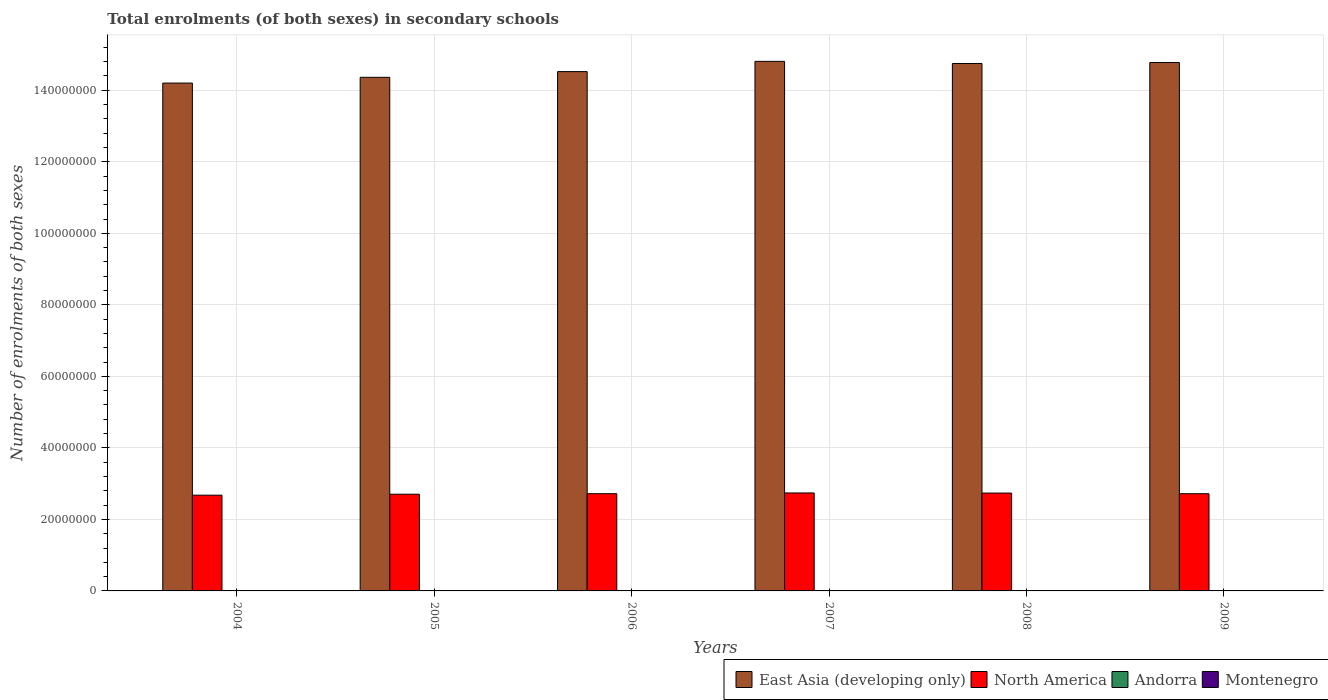How many different coloured bars are there?
Your answer should be compact. 4. How many groups of bars are there?
Provide a succinct answer. 6. Are the number of bars per tick equal to the number of legend labels?
Give a very brief answer. Yes. Are the number of bars on each tick of the X-axis equal?
Your response must be concise. Yes. How many bars are there on the 5th tick from the right?
Offer a terse response. 4. What is the number of enrolments in secondary schools in North America in 2005?
Provide a succinct answer. 2.70e+07. Across all years, what is the maximum number of enrolments in secondary schools in North America?
Ensure brevity in your answer.  2.74e+07. Across all years, what is the minimum number of enrolments in secondary schools in Andorra?
Give a very brief answer. 3250. In which year was the number of enrolments in secondary schools in Andorra minimum?
Make the answer very short. 2004. What is the total number of enrolments in secondary schools in Andorra in the graph?
Your answer should be compact. 2.24e+04. What is the difference between the number of enrolments in secondary schools in East Asia (developing only) in 2007 and that in 2008?
Keep it short and to the point. 5.97e+05. What is the difference between the number of enrolments in secondary schools in Andorra in 2008 and the number of enrolments in secondary schools in Montenegro in 2005?
Provide a succinct answer. -6.46e+04. What is the average number of enrolments in secondary schools in North America per year?
Your answer should be compact. 2.72e+07. In the year 2005, what is the difference between the number of enrolments in secondary schools in Montenegro and number of enrolments in secondary schools in North America?
Provide a short and direct response. -2.70e+07. What is the ratio of the number of enrolments in secondary schools in Montenegro in 2004 to that in 2008?
Your response must be concise. 1.03. What is the difference between the highest and the second highest number of enrolments in secondary schools in East Asia (developing only)?
Provide a short and direct response. 3.27e+05. What is the difference between the highest and the lowest number of enrolments in secondary schools in East Asia (developing only)?
Your answer should be compact. 6.07e+06. Is the sum of the number of enrolments in secondary schools in Montenegro in 2005 and 2007 greater than the maximum number of enrolments in secondary schools in North America across all years?
Provide a succinct answer. No. Is it the case that in every year, the sum of the number of enrolments in secondary schools in North America and number of enrolments in secondary schools in Montenegro is greater than the sum of number of enrolments in secondary schools in East Asia (developing only) and number of enrolments in secondary schools in Andorra?
Provide a succinct answer. No. What does the 4th bar from the left in 2006 represents?
Offer a terse response. Montenegro. What does the 1st bar from the right in 2006 represents?
Make the answer very short. Montenegro. Are all the bars in the graph horizontal?
Your answer should be very brief. No. How many years are there in the graph?
Ensure brevity in your answer.  6. Are the values on the major ticks of Y-axis written in scientific E-notation?
Give a very brief answer. No. Where does the legend appear in the graph?
Your response must be concise. Bottom right. How many legend labels are there?
Your answer should be compact. 4. What is the title of the graph?
Make the answer very short. Total enrolments (of both sexes) in secondary schools. Does "Vietnam" appear as one of the legend labels in the graph?
Your answer should be very brief. No. What is the label or title of the X-axis?
Offer a very short reply. Years. What is the label or title of the Y-axis?
Ensure brevity in your answer.  Number of enrolments of both sexes. What is the Number of enrolments of both sexes of East Asia (developing only) in 2004?
Your answer should be compact. 1.42e+08. What is the Number of enrolments of both sexes of North America in 2004?
Make the answer very short. 2.68e+07. What is the Number of enrolments of both sexes in Andorra in 2004?
Ensure brevity in your answer.  3250. What is the Number of enrolments of both sexes of Montenegro in 2004?
Keep it short and to the point. 6.88e+04. What is the Number of enrolments of both sexes of East Asia (developing only) in 2005?
Give a very brief answer. 1.44e+08. What is the Number of enrolments of both sexes in North America in 2005?
Make the answer very short. 2.70e+07. What is the Number of enrolments of both sexes of Andorra in 2005?
Offer a terse response. 3737. What is the Number of enrolments of both sexes of Montenegro in 2005?
Offer a very short reply. 6.85e+04. What is the Number of enrolments of both sexes in East Asia (developing only) in 2006?
Your answer should be very brief. 1.45e+08. What is the Number of enrolments of both sexes of North America in 2006?
Offer a terse response. 2.72e+07. What is the Number of enrolments of both sexes in Andorra in 2006?
Provide a succinct answer. 3843. What is the Number of enrolments of both sexes of Montenegro in 2006?
Make the answer very short. 6.82e+04. What is the Number of enrolments of both sexes of East Asia (developing only) in 2007?
Offer a very short reply. 1.48e+08. What is the Number of enrolments of both sexes in North America in 2007?
Ensure brevity in your answer.  2.74e+07. What is the Number of enrolments of both sexes of Andorra in 2007?
Offer a very short reply. 3819. What is the Number of enrolments of both sexes of Montenegro in 2007?
Give a very brief answer. 6.77e+04. What is the Number of enrolments of both sexes in East Asia (developing only) in 2008?
Keep it short and to the point. 1.47e+08. What is the Number of enrolments of both sexes in North America in 2008?
Your answer should be very brief. 2.74e+07. What is the Number of enrolments of both sexes of Andorra in 2008?
Your response must be concise. 3851. What is the Number of enrolments of both sexes in Montenegro in 2008?
Your response must be concise. 6.70e+04. What is the Number of enrolments of both sexes in East Asia (developing only) in 2009?
Your answer should be very brief. 1.48e+08. What is the Number of enrolments of both sexes of North America in 2009?
Provide a succinct answer. 2.72e+07. What is the Number of enrolments of both sexes of Andorra in 2009?
Give a very brief answer. 3914. What is the Number of enrolments of both sexes in Montenegro in 2009?
Offer a terse response. 6.81e+04. Across all years, what is the maximum Number of enrolments of both sexes in East Asia (developing only)?
Provide a succinct answer. 1.48e+08. Across all years, what is the maximum Number of enrolments of both sexes in North America?
Provide a succinct answer. 2.74e+07. Across all years, what is the maximum Number of enrolments of both sexes of Andorra?
Provide a succinct answer. 3914. Across all years, what is the maximum Number of enrolments of both sexes in Montenegro?
Offer a very short reply. 6.88e+04. Across all years, what is the minimum Number of enrolments of both sexes of East Asia (developing only)?
Your answer should be very brief. 1.42e+08. Across all years, what is the minimum Number of enrolments of both sexes in North America?
Ensure brevity in your answer.  2.68e+07. Across all years, what is the minimum Number of enrolments of both sexes in Andorra?
Provide a succinct answer. 3250. Across all years, what is the minimum Number of enrolments of both sexes of Montenegro?
Your answer should be compact. 6.70e+04. What is the total Number of enrolments of both sexes of East Asia (developing only) in the graph?
Ensure brevity in your answer.  8.74e+08. What is the total Number of enrolments of both sexes of North America in the graph?
Give a very brief answer. 1.63e+08. What is the total Number of enrolments of both sexes of Andorra in the graph?
Your answer should be compact. 2.24e+04. What is the total Number of enrolments of both sexes of Montenegro in the graph?
Offer a very short reply. 4.08e+05. What is the difference between the Number of enrolments of both sexes in East Asia (developing only) in 2004 and that in 2005?
Your answer should be very brief. -1.61e+06. What is the difference between the Number of enrolments of both sexes of North America in 2004 and that in 2005?
Offer a very short reply. -2.65e+05. What is the difference between the Number of enrolments of both sexes of Andorra in 2004 and that in 2005?
Offer a terse response. -487. What is the difference between the Number of enrolments of both sexes of Montenegro in 2004 and that in 2005?
Keep it short and to the point. 336. What is the difference between the Number of enrolments of both sexes in East Asia (developing only) in 2004 and that in 2006?
Ensure brevity in your answer.  -3.21e+06. What is the difference between the Number of enrolments of both sexes in North America in 2004 and that in 2006?
Provide a short and direct response. -4.16e+05. What is the difference between the Number of enrolments of both sexes in Andorra in 2004 and that in 2006?
Keep it short and to the point. -593. What is the difference between the Number of enrolments of both sexes of Montenegro in 2004 and that in 2006?
Offer a terse response. 589. What is the difference between the Number of enrolments of both sexes of East Asia (developing only) in 2004 and that in 2007?
Offer a terse response. -6.07e+06. What is the difference between the Number of enrolments of both sexes of North America in 2004 and that in 2007?
Offer a very short reply. -6.19e+05. What is the difference between the Number of enrolments of both sexes in Andorra in 2004 and that in 2007?
Provide a succinct answer. -569. What is the difference between the Number of enrolments of both sexes in Montenegro in 2004 and that in 2007?
Your answer should be very brief. 1124. What is the difference between the Number of enrolments of both sexes of East Asia (developing only) in 2004 and that in 2008?
Ensure brevity in your answer.  -5.48e+06. What is the difference between the Number of enrolments of both sexes in North America in 2004 and that in 2008?
Give a very brief answer. -5.92e+05. What is the difference between the Number of enrolments of both sexes in Andorra in 2004 and that in 2008?
Give a very brief answer. -601. What is the difference between the Number of enrolments of both sexes in Montenegro in 2004 and that in 2008?
Your answer should be compact. 1792. What is the difference between the Number of enrolments of both sexes in East Asia (developing only) in 2004 and that in 2009?
Provide a short and direct response. -5.75e+06. What is the difference between the Number of enrolments of both sexes in North America in 2004 and that in 2009?
Offer a very short reply. -4.13e+05. What is the difference between the Number of enrolments of both sexes of Andorra in 2004 and that in 2009?
Provide a succinct answer. -664. What is the difference between the Number of enrolments of both sexes of Montenegro in 2004 and that in 2009?
Offer a very short reply. 672. What is the difference between the Number of enrolments of both sexes in East Asia (developing only) in 2005 and that in 2006?
Provide a short and direct response. -1.60e+06. What is the difference between the Number of enrolments of both sexes in North America in 2005 and that in 2006?
Give a very brief answer. -1.51e+05. What is the difference between the Number of enrolments of both sexes of Andorra in 2005 and that in 2006?
Make the answer very short. -106. What is the difference between the Number of enrolments of both sexes in Montenegro in 2005 and that in 2006?
Your response must be concise. 253. What is the difference between the Number of enrolments of both sexes in East Asia (developing only) in 2005 and that in 2007?
Your answer should be compact. -4.46e+06. What is the difference between the Number of enrolments of both sexes in North America in 2005 and that in 2007?
Provide a short and direct response. -3.54e+05. What is the difference between the Number of enrolments of both sexes in Andorra in 2005 and that in 2007?
Give a very brief answer. -82. What is the difference between the Number of enrolments of both sexes in Montenegro in 2005 and that in 2007?
Your answer should be very brief. 788. What is the difference between the Number of enrolments of both sexes of East Asia (developing only) in 2005 and that in 2008?
Offer a terse response. -3.87e+06. What is the difference between the Number of enrolments of both sexes of North America in 2005 and that in 2008?
Offer a very short reply. -3.27e+05. What is the difference between the Number of enrolments of both sexes of Andorra in 2005 and that in 2008?
Your answer should be very brief. -114. What is the difference between the Number of enrolments of both sexes in Montenegro in 2005 and that in 2008?
Your answer should be compact. 1456. What is the difference between the Number of enrolments of both sexes in East Asia (developing only) in 2005 and that in 2009?
Your answer should be very brief. -4.14e+06. What is the difference between the Number of enrolments of both sexes of North America in 2005 and that in 2009?
Your answer should be compact. -1.48e+05. What is the difference between the Number of enrolments of both sexes of Andorra in 2005 and that in 2009?
Give a very brief answer. -177. What is the difference between the Number of enrolments of both sexes of Montenegro in 2005 and that in 2009?
Offer a terse response. 336. What is the difference between the Number of enrolments of both sexes in East Asia (developing only) in 2006 and that in 2007?
Keep it short and to the point. -2.87e+06. What is the difference between the Number of enrolments of both sexes in North America in 2006 and that in 2007?
Provide a short and direct response. -2.04e+05. What is the difference between the Number of enrolments of both sexes of Andorra in 2006 and that in 2007?
Give a very brief answer. 24. What is the difference between the Number of enrolments of both sexes in Montenegro in 2006 and that in 2007?
Offer a terse response. 535. What is the difference between the Number of enrolments of both sexes of East Asia (developing only) in 2006 and that in 2008?
Provide a short and direct response. -2.27e+06. What is the difference between the Number of enrolments of both sexes of North America in 2006 and that in 2008?
Your answer should be compact. -1.76e+05. What is the difference between the Number of enrolments of both sexes of Andorra in 2006 and that in 2008?
Provide a short and direct response. -8. What is the difference between the Number of enrolments of both sexes of Montenegro in 2006 and that in 2008?
Keep it short and to the point. 1203. What is the difference between the Number of enrolments of both sexes of East Asia (developing only) in 2006 and that in 2009?
Provide a succinct answer. -2.54e+06. What is the difference between the Number of enrolments of both sexes in North America in 2006 and that in 2009?
Your response must be concise. 2344. What is the difference between the Number of enrolments of both sexes in Andorra in 2006 and that in 2009?
Keep it short and to the point. -71. What is the difference between the Number of enrolments of both sexes in Montenegro in 2006 and that in 2009?
Your response must be concise. 83. What is the difference between the Number of enrolments of both sexes of East Asia (developing only) in 2007 and that in 2008?
Your answer should be compact. 5.97e+05. What is the difference between the Number of enrolments of both sexes of North America in 2007 and that in 2008?
Give a very brief answer. 2.74e+04. What is the difference between the Number of enrolments of both sexes in Andorra in 2007 and that in 2008?
Make the answer very short. -32. What is the difference between the Number of enrolments of both sexes of Montenegro in 2007 and that in 2008?
Your answer should be very brief. 668. What is the difference between the Number of enrolments of both sexes of East Asia (developing only) in 2007 and that in 2009?
Your answer should be compact. 3.27e+05. What is the difference between the Number of enrolments of both sexes in North America in 2007 and that in 2009?
Keep it short and to the point. 2.06e+05. What is the difference between the Number of enrolments of both sexes in Andorra in 2007 and that in 2009?
Give a very brief answer. -95. What is the difference between the Number of enrolments of both sexes in Montenegro in 2007 and that in 2009?
Your response must be concise. -452. What is the difference between the Number of enrolments of both sexes of East Asia (developing only) in 2008 and that in 2009?
Provide a short and direct response. -2.70e+05. What is the difference between the Number of enrolments of both sexes of North America in 2008 and that in 2009?
Your answer should be compact. 1.79e+05. What is the difference between the Number of enrolments of both sexes in Andorra in 2008 and that in 2009?
Make the answer very short. -63. What is the difference between the Number of enrolments of both sexes of Montenegro in 2008 and that in 2009?
Your answer should be compact. -1120. What is the difference between the Number of enrolments of both sexes of East Asia (developing only) in 2004 and the Number of enrolments of both sexes of North America in 2005?
Give a very brief answer. 1.15e+08. What is the difference between the Number of enrolments of both sexes of East Asia (developing only) in 2004 and the Number of enrolments of both sexes of Andorra in 2005?
Keep it short and to the point. 1.42e+08. What is the difference between the Number of enrolments of both sexes in East Asia (developing only) in 2004 and the Number of enrolments of both sexes in Montenegro in 2005?
Offer a very short reply. 1.42e+08. What is the difference between the Number of enrolments of both sexes in North America in 2004 and the Number of enrolments of both sexes in Andorra in 2005?
Provide a succinct answer. 2.68e+07. What is the difference between the Number of enrolments of both sexes of North America in 2004 and the Number of enrolments of both sexes of Montenegro in 2005?
Ensure brevity in your answer.  2.67e+07. What is the difference between the Number of enrolments of both sexes of Andorra in 2004 and the Number of enrolments of both sexes of Montenegro in 2005?
Your answer should be compact. -6.52e+04. What is the difference between the Number of enrolments of both sexes of East Asia (developing only) in 2004 and the Number of enrolments of both sexes of North America in 2006?
Keep it short and to the point. 1.15e+08. What is the difference between the Number of enrolments of both sexes in East Asia (developing only) in 2004 and the Number of enrolments of both sexes in Andorra in 2006?
Your response must be concise. 1.42e+08. What is the difference between the Number of enrolments of both sexes of East Asia (developing only) in 2004 and the Number of enrolments of both sexes of Montenegro in 2006?
Provide a short and direct response. 1.42e+08. What is the difference between the Number of enrolments of both sexes in North America in 2004 and the Number of enrolments of both sexes in Andorra in 2006?
Provide a short and direct response. 2.68e+07. What is the difference between the Number of enrolments of both sexes in North America in 2004 and the Number of enrolments of both sexes in Montenegro in 2006?
Keep it short and to the point. 2.67e+07. What is the difference between the Number of enrolments of both sexes in Andorra in 2004 and the Number of enrolments of both sexes in Montenegro in 2006?
Provide a short and direct response. -6.50e+04. What is the difference between the Number of enrolments of both sexes of East Asia (developing only) in 2004 and the Number of enrolments of both sexes of North America in 2007?
Provide a short and direct response. 1.15e+08. What is the difference between the Number of enrolments of both sexes of East Asia (developing only) in 2004 and the Number of enrolments of both sexes of Andorra in 2007?
Offer a very short reply. 1.42e+08. What is the difference between the Number of enrolments of both sexes of East Asia (developing only) in 2004 and the Number of enrolments of both sexes of Montenegro in 2007?
Your response must be concise. 1.42e+08. What is the difference between the Number of enrolments of both sexes in North America in 2004 and the Number of enrolments of both sexes in Andorra in 2007?
Give a very brief answer. 2.68e+07. What is the difference between the Number of enrolments of both sexes of North America in 2004 and the Number of enrolments of both sexes of Montenegro in 2007?
Provide a short and direct response. 2.67e+07. What is the difference between the Number of enrolments of both sexes of Andorra in 2004 and the Number of enrolments of both sexes of Montenegro in 2007?
Offer a terse response. -6.44e+04. What is the difference between the Number of enrolments of both sexes in East Asia (developing only) in 2004 and the Number of enrolments of both sexes in North America in 2008?
Your answer should be very brief. 1.15e+08. What is the difference between the Number of enrolments of both sexes in East Asia (developing only) in 2004 and the Number of enrolments of both sexes in Andorra in 2008?
Provide a short and direct response. 1.42e+08. What is the difference between the Number of enrolments of both sexes in East Asia (developing only) in 2004 and the Number of enrolments of both sexes in Montenegro in 2008?
Offer a very short reply. 1.42e+08. What is the difference between the Number of enrolments of both sexes of North America in 2004 and the Number of enrolments of both sexes of Andorra in 2008?
Provide a short and direct response. 2.68e+07. What is the difference between the Number of enrolments of both sexes in North America in 2004 and the Number of enrolments of both sexes in Montenegro in 2008?
Offer a very short reply. 2.67e+07. What is the difference between the Number of enrolments of both sexes in Andorra in 2004 and the Number of enrolments of both sexes in Montenegro in 2008?
Ensure brevity in your answer.  -6.38e+04. What is the difference between the Number of enrolments of both sexes of East Asia (developing only) in 2004 and the Number of enrolments of both sexes of North America in 2009?
Your answer should be compact. 1.15e+08. What is the difference between the Number of enrolments of both sexes in East Asia (developing only) in 2004 and the Number of enrolments of both sexes in Andorra in 2009?
Your answer should be compact. 1.42e+08. What is the difference between the Number of enrolments of both sexes in East Asia (developing only) in 2004 and the Number of enrolments of both sexes in Montenegro in 2009?
Provide a short and direct response. 1.42e+08. What is the difference between the Number of enrolments of both sexes of North America in 2004 and the Number of enrolments of both sexes of Andorra in 2009?
Provide a succinct answer. 2.68e+07. What is the difference between the Number of enrolments of both sexes of North America in 2004 and the Number of enrolments of both sexes of Montenegro in 2009?
Provide a short and direct response. 2.67e+07. What is the difference between the Number of enrolments of both sexes of Andorra in 2004 and the Number of enrolments of both sexes of Montenegro in 2009?
Provide a succinct answer. -6.49e+04. What is the difference between the Number of enrolments of both sexes in East Asia (developing only) in 2005 and the Number of enrolments of both sexes in North America in 2006?
Your response must be concise. 1.16e+08. What is the difference between the Number of enrolments of both sexes in East Asia (developing only) in 2005 and the Number of enrolments of both sexes in Andorra in 2006?
Provide a short and direct response. 1.44e+08. What is the difference between the Number of enrolments of both sexes of East Asia (developing only) in 2005 and the Number of enrolments of both sexes of Montenegro in 2006?
Your answer should be very brief. 1.44e+08. What is the difference between the Number of enrolments of both sexes in North America in 2005 and the Number of enrolments of both sexes in Andorra in 2006?
Offer a terse response. 2.70e+07. What is the difference between the Number of enrolments of both sexes in North America in 2005 and the Number of enrolments of both sexes in Montenegro in 2006?
Your answer should be compact. 2.70e+07. What is the difference between the Number of enrolments of both sexes of Andorra in 2005 and the Number of enrolments of both sexes of Montenegro in 2006?
Give a very brief answer. -6.45e+04. What is the difference between the Number of enrolments of both sexes of East Asia (developing only) in 2005 and the Number of enrolments of both sexes of North America in 2007?
Your response must be concise. 1.16e+08. What is the difference between the Number of enrolments of both sexes of East Asia (developing only) in 2005 and the Number of enrolments of both sexes of Andorra in 2007?
Ensure brevity in your answer.  1.44e+08. What is the difference between the Number of enrolments of both sexes of East Asia (developing only) in 2005 and the Number of enrolments of both sexes of Montenegro in 2007?
Offer a terse response. 1.44e+08. What is the difference between the Number of enrolments of both sexes in North America in 2005 and the Number of enrolments of both sexes in Andorra in 2007?
Your answer should be very brief. 2.70e+07. What is the difference between the Number of enrolments of both sexes of North America in 2005 and the Number of enrolments of both sexes of Montenegro in 2007?
Your response must be concise. 2.70e+07. What is the difference between the Number of enrolments of both sexes of Andorra in 2005 and the Number of enrolments of both sexes of Montenegro in 2007?
Your answer should be very brief. -6.39e+04. What is the difference between the Number of enrolments of both sexes in East Asia (developing only) in 2005 and the Number of enrolments of both sexes in North America in 2008?
Make the answer very short. 1.16e+08. What is the difference between the Number of enrolments of both sexes of East Asia (developing only) in 2005 and the Number of enrolments of both sexes of Andorra in 2008?
Provide a short and direct response. 1.44e+08. What is the difference between the Number of enrolments of both sexes of East Asia (developing only) in 2005 and the Number of enrolments of both sexes of Montenegro in 2008?
Make the answer very short. 1.44e+08. What is the difference between the Number of enrolments of both sexes of North America in 2005 and the Number of enrolments of both sexes of Andorra in 2008?
Offer a very short reply. 2.70e+07. What is the difference between the Number of enrolments of both sexes of North America in 2005 and the Number of enrolments of both sexes of Montenegro in 2008?
Keep it short and to the point. 2.70e+07. What is the difference between the Number of enrolments of both sexes of Andorra in 2005 and the Number of enrolments of both sexes of Montenegro in 2008?
Make the answer very short. -6.33e+04. What is the difference between the Number of enrolments of both sexes in East Asia (developing only) in 2005 and the Number of enrolments of both sexes in North America in 2009?
Keep it short and to the point. 1.16e+08. What is the difference between the Number of enrolments of both sexes in East Asia (developing only) in 2005 and the Number of enrolments of both sexes in Andorra in 2009?
Provide a succinct answer. 1.44e+08. What is the difference between the Number of enrolments of both sexes of East Asia (developing only) in 2005 and the Number of enrolments of both sexes of Montenegro in 2009?
Give a very brief answer. 1.44e+08. What is the difference between the Number of enrolments of both sexes of North America in 2005 and the Number of enrolments of both sexes of Andorra in 2009?
Your answer should be very brief. 2.70e+07. What is the difference between the Number of enrolments of both sexes in North America in 2005 and the Number of enrolments of both sexes in Montenegro in 2009?
Keep it short and to the point. 2.70e+07. What is the difference between the Number of enrolments of both sexes in Andorra in 2005 and the Number of enrolments of both sexes in Montenegro in 2009?
Offer a terse response. -6.44e+04. What is the difference between the Number of enrolments of both sexes of East Asia (developing only) in 2006 and the Number of enrolments of both sexes of North America in 2007?
Give a very brief answer. 1.18e+08. What is the difference between the Number of enrolments of both sexes in East Asia (developing only) in 2006 and the Number of enrolments of both sexes in Andorra in 2007?
Provide a succinct answer. 1.45e+08. What is the difference between the Number of enrolments of both sexes in East Asia (developing only) in 2006 and the Number of enrolments of both sexes in Montenegro in 2007?
Ensure brevity in your answer.  1.45e+08. What is the difference between the Number of enrolments of both sexes in North America in 2006 and the Number of enrolments of both sexes in Andorra in 2007?
Your answer should be very brief. 2.72e+07. What is the difference between the Number of enrolments of both sexes in North America in 2006 and the Number of enrolments of both sexes in Montenegro in 2007?
Your answer should be very brief. 2.71e+07. What is the difference between the Number of enrolments of both sexes in Andorra in 2006 and the Number of enrolments of both sexes in Montenegro in 2007?
Ensure brevity in your answer.  -6.38e+04. What is the difference between the Number of enrolments of both sexes of East Asia (developing only) in 2006 and the Number of enrolments of both sexes of North America in 2008?
Make the answer very short. 1.18e+08. What is the difference between the Number of enrolments of both sexes of East Asia (developing only) in 2006 and the Number of enrolments of both sexes of Andorra in 2008?
Ensure brevity in your answer.  1.45e+08. What is the difference between the Number of enrolments of both sexes in East Asia (developing only) in 2006 and the Number of enrolments of both sexes in Montenegro in 2008?
Keep it short and to the point. 1.45e+08. What is the difference between the Number of enrolments of both sexes in North America in 2006 and the Number of enrolments of both sexes in Andorra in 2008?
Offer a very short reply. 2.72e+07. What is the difference between the Number of enrolments of both sexes of North America in 2006 and the Number of enrolments of both sexes of Montenegro in 2008?
Make the answer very short. 2.71e+07. What is the difference between the Number of enrolments of both sexes of Andorra in 2006 and the Number of enrolments of both sexes of Montenegro in 2008?
Your response must be concise. -6.32e+04. What is the difference between the Number of enrolments of both sexes in East Asia (developing only) in 2006 and the Number of enrolments of both sexes in North America in 2009?
Keep it short and to the point. 1.18e+08. What is the difference between the Number of enrolments of both sexes of East Asia (developing only) in 2006 and the Number of enrolments of both sexes of Andorra in 2009?
Provide a succinct answer. 1.45e+08. What is the difference between the Number of enrolments of both sexes in East Asia (developing only) in 2006 and the Number of enrolments of both sexes in Montenegro in 2009?
Keep it short and to the point. 1.45e+08. What is the difference between the Number of enrolments of both sexes of North America in 2006 and the Number of enrolments of both sexes of Andorra in 2009?
Provide a succinct answer. 2.72e+07. What is the difference between the Number of enrolments of both sexes in North America in 2006 and the Number of enrolments of both sexes in Montenegro in 2009?
Offer a very short reply. 2.71e+07. What is the difference between the Number of enrolments of both sexes of Andorra in 2006 and the Number of enrolments of both sexes of Montenegro in 2009?
Keep it short and to the point. -6.43e+04. What is the difference between the Number of enrolments of both sexes in East Asia (developing only) in 2007 and the Number of enrolments of both sexes in North America in 2008?
Give a very brief answer. 1.21e+08. What is the difference between the Number of enrolments of both sexes of East Asia (developing only) in 2007 and the Number of enrolments of both sexes of Andorra in 2008?
Offer a terse response. 1.48e+08. What is the difference between the Number of enrolments of both sexes of East Asia (developing only) in 2007 and the Number of enrolments of both sexes of Montenegro in 2008?
Provide a succinct answer. 1.48e+08. What is the difference between the Number of enrolments of both sexes of North America in 2007 and the Number of enrolments of both sexes of Andorra in 2008?
Make the answer very short. 2.74e+07. What is the difference between the Number of enrolments of both sexes of North America in 2007 and the Number of enrolments of both sexes of Montenegro in 2008?
Provide a succinct answer. 2.73e+07. What is the difference between the Number of enrolments of both sexes in Andorra in 2007 and the Number of enrolments of both sexes in Montenegro in 2008?
Offer a very short reply. -6.32e+04. What is the difference between the Number of enrolments of both sexes of East Asia (developing only) in 2007 and the Number of enrolments of both sexes of North America in 2009?
Your response must be concise. 1.21e+08. What is the difference between the Number of enrolments of both sexes in East Asia (developing only) in 2007 and the Number of enrolments of both sexes in Andorra in 2009?
Provide a succinct answer. 1.48e+08. What is the difference between the Number of enrolments of both sexes in East Asia (developing only) in 2007 and the Number of enrolments of both sexes in Montenegro in 2009?
Keep it short and to the point. 1.48e+08. What is the difference between the Number of enrolments of both sexes in North America in 2007 and the Number of enrolments of both sexes in Andorra in 2009?
Provide a succinct answer. 2.74e+07. What is the difference between the Number of enrolments of both sexes of North America in 2007 and the Number of enrolments of both sexes of Montenegro in 2009?
Offer a terse response. 2.73e+07. What is the difference between the Number of enrolments of both sexes of Andorra in 2007 and the Number of enrolments of both sexes of Montenegro in 2009?
Your answer should be very brief. -6.43e+04. What is the difference between the Number of enrolments of both sexes in East Asia (developing only) in 2008 and the Number of enrolments of both sexes in North America in 2009?
Your response must be concise. 1.20e+08. What is the difference between the Number of enrolments of both sexes of East Asia (developing only) in 2008 and the Number of enrolments of both sexes of Andorra in 2009?
Give a very brief answer. 1.47e+08. What is the difference between the Number of enrolments of both sexes of East Asia (developing only) in 2008 and the Number of enrolments of both sexes of Montenegro in 2009?
Your answer should be compact. 1.47e+08. What is the difference between the Number of enrolments of both sexes in North America in 2008 and the Number of enrolments of both sexes in Andorra in 2009?
Keep it short and to the point. 2.74e+07. What is the difference between the Number of enrolments of both sexes in North America in 2008 and the Number of enrolments of both sexes in Montenegro in 2009?
Provide a succinct answer. 2.73e+07. What is the difference between the Number of enrolments of both sexes of Andorra in 2008 and the Number of enrolments of both sexes of Montenegro in 2009?
Offer a very short reply. -6.43e+04. What is the average Number of enrolments of both sexes of East Asia (developing only) per year?
Your answer should be very brief. 1.46e+08. What is the average Number of enrolments of both sexes in North America per year?
Offer a very short reply. 2.72e+07. What is the average Number of enrolments of both sexes of Andorra per year?
Ensure brevity in your answer.  3735.67. What is the average Number of enrolments of both sexes in Montenegro per year?
Keep it short and to the point. 6.81e+04. In the year 2004, what is the difference between the Number of enrolments of both sexes of East Asia (developing only) and Number of enrolments of both sexes of North America?
Your response must be concise. 1.15e+08. In the year 2004, what is the difference between the Number of enrolments of both sexes in East Asia (developing only) and Number of enrolments of both sexes in Andorra?
Your response must be concise. 1.42e+08. In the year 2004, what is the difference between the Number of enrolments of both sexes in East Asia (developing only) and Number of enrolments of both sexes in Montenegro?
Provide a succinct answer. 1.42e+08. In the year 2004, what is the difference between the Number of enrolments of both sexes in North America and Number of enrolments of both sexes in Andorra?
Make the answer very short. 2.68e+07. In the year 2004, what is the difference between the Number of enrolments of both sexes of North America and Number of enrolments of both sexes of Montenegro?
Keep it short and to the point. 2.67e+07. In the year 2004, what is the difference between the Number of enrolments of both sexes of Andorra and Number of enrolments of both sexes of Montenegro?
Your answer should be compact. -6.56e+04. In the year 2005, what is the difference between the Number of enrolments of both sexes of East Asia (developing only) and Number of enrolments of both sexes of North America?
Offer a terse response. 1.17e+08. In the year 2005, what is the difference between the Number of enrolments of both sexes in East Asia (developing only) and Number of enrolments of both sexes in Andorra?
Make the answer very short. 1.44e+08. In the year 2005, what is the difference between the Number of enrolments of both sexes in East Asia (developing only) and Number of enrolments of both sexes in Montenegro?
Make the answer very short. 1.44e+08. In the year 2005, what is the difference between the Number of enrolments of both sexes of North America and Number of enrolments of both sexes of Andorra?
Offer a very short reply. 2.70e+07. In the year 2005, what is the difference between the Number of enrolments of both sexes in North America and Number of enrolments of both sexes in Montenegro?
Make the answer very short. 2.70e+07. In the year 2005, what is the difference between the Number of enrolments of both sexes of Andorra and Number of enrolments of both sexes of Montenegro?
Provide a short and direct response. -6.47e+04. In the year 2006, what is the difference between the Number of enrolments of both sexes in East Asia (developing only) and Number of enrolments of both sexes in North America?
Make the answer very short. 1.18e+08. In the year 2006, what is the difference between the Number of enrolments of both sexes in East Asia (developing only) and Number of enrolments of both sexes in Andorra?
Offer a terse response. 1.45e+08. In the year 2006, what is the difference between the Number of enrolments of both sexes of East Asia (developing only) and Number of enrolments of both sexes of Montenegro?
Provide a short and direct response. 1.45e+08. In the year 2006, what is the difference between the Number of enrolments of both sexes of North America and Number of enrolments of both sexes of Andorra?
Keep it short and to the point. 2.72e+07. In the year 2006, what is the difference between the Number of enrolments of both sexes of North America and Number of enrolments of both sexes of Montenegro?
Keep it short and to the point. 2.71e+07. In the year 2006, what is the difference between the Number of enrolments of both sexes in Andorra and Number of enrolments of both sexes in Montenegro?
Keep it short and to the point. -6.44e+04. In the year 2007, what is the difference between the Number of enrolments of both sexes of East Asia (developing only) and Number of enrolments of both sexes of North America?
Provide a short and direct response. 1.21e+08. In the year 2007, what is the difference between the Number of enrolments of both sexes of East Asia (developing only) and Number of enrolments of both sexes of Andorra?
Offer a very short reply. 1.48e+08. In the year 2007, what is the difference between the Number of enrolments of both sexes in East Asia (developing only) and Number of enrolments of both sexes in Montenegro?
Make the answer very short. 1.48e+08. In the year 2007, what is the difference between the Number of enrolments of both sexes of North America and Number of enrolments of both sexes of Andorra?
Your answer should be very brief. 2.74e+07. In the year 2007, what is the difference between the Number of enrolments of both sexes in North America and Number of enrolments of both sexes in Montenegro?
Offer a terse response. 2.73e+07. In the year 2007, what is the difference between the Number of enrolments of both sexes in Andorra and Number of enrolments of both sexes in Montenegro?
Your answer should be compact. -6.39e+04. In the year 2008, what is the difference between the Number of enrolments of both sexes in East Asia (developing only) and Number of enrolments of both sexes in North America?
Offer a very short reply. 1.20e+08. In the year 2008, what is the difference between the Number of enrolments of both sexes of East Asia (developing only) and Number of enrolments of both sexes of Andorra?
Offer a very short reply. 1.47e+08. In the year 2008, what is the difference between the Number of enrolments of both sexes of East Asia (developing only) and Number of enrolments of both sexes of Montenegro?
Keep it short and to the point. 1.47e+08. In the year 2008, what is the difference between the Number of enrolments of both sexes of North America and Number of enrolments of both sexes of Andorra?
Your answer should be compact. 2.74e+07. In the year 2008, what is the difference between the Number of enrolments of both sexes in North America and Number of enrolments of both sexes in Montenegro?
Give a very brief answer. 2.73e+07. In the year 2008, what is the difference between the Number of enrolments of both sexes of Andorra and Number of enrolments of both sexes of Montenegro?
Your answer should be very brief. -6.32e+04. In the year 2009, what is the difference between the Number of enrolments of both sexes of East Asia (developing only) and Number of enrolments of both sexes of North America?
Provide a succinct answer. 1.21e+08. In the year 2009, what is the difference between the Number of enrolments of both sexes of East Asia (developing only) and Number of enrolments of both sexes of Andorra?
Keep it short and to the point. 1.48e+08. In the year 2009, what is the difference between the Number of enrolments of both sexes of East Asia (developing only) and Number of enrolments of both sexes of Montenegro?
Offer a very short reply. 1.48e+08. In the year 2009, what is the difference between the Number of enrolments of both sexes of North America and Number of enrolments of both sexes of Andorra?
Provide a succinct answer. 2.72e+07. In the year 2009, what is the difference between the Number of enrolments of both sexes in North America and Number of enrolments of both sexes in Montenegro?
Make the answer very short. 2.71e+07. In the year 2009, what is the difference between the Number of enrolments of both sexes in Andorra and Number of enrolments of both sexes in Montenegro?
Give a very brief answer. -6.42e+04. What is the ratio of the Number of enrolments of both sexes of East Asia (developing only) in 2004 to that in 2005?
Offer a terse response. 0.99. What is the ratio of the Number of enrolments of both sexes in North America in 2004 to that in 2005?
Give a very brief answer. 0.99. What is the ratio of the Number of enrolments of both sexes of Andorra in 2004 to that in 2005?
Make the answer very short. 0.87. What is the ratio of the Number of enrolments of both sexes of East Asia (developing only) in 2004 to that in 2006?
Provide a short and direct response. 0.98. What is the ratio of the Number of enrolments of both sexes in North America in 2004 to that in 2006?
Provide a succinct answer. 0.98. What is the ratio of the Number of enrolments of both sexes of Andorra in 2004 to that in 2006?
Keep it short and to the point. 0.85. What is the ratio of the Number of enrolments of both sexes of Montenegro in 2004 to that in 2006?
Make the answer very short. 1.01. What is the ratio of the Number of enrolments of both sexes in North America in 2004 to that in 2007?
Keep it short and to the point. 0.98. What is the ratio of the Number of enrolments of both sexes in Andorra in 2004 to that in 2007?
Provide a succinct answer. 0.85. What is the ratio of the Number of enrolments of both sexes of Montenegro in 2004 to that in 2007?
Your answer should be compact. 1.02. What is the ratio of the Number of enrolments of both sexes of East Asia (developing only) in 2004 to that in 2008?
Give a very brief answer. 0.96. What is the ratio of the Number of enrolments of both sexes of North America in 2004 to that in 2008?
Your answer should be very brief. 0.98. What is the ratio of the Number of enrolments of both sexes in Andorra in 2004 to that in 2008?
Offer a very short reply. 0.84. What is the ratio of the Number of enrolments of both sexes in Montenegro in 2004 to that in 2008?
Make the answer very short. 1.03. What is the ratio of the Number of enrolments of both sexes in East Asia (developing only) in 2004 to that in 2009?
Offer a very short reply. 0.96. What is the ratio of the Number of enrolments of both sexes of North America in 2004 to that in 2009?
Your answer should be very brief. 0.98. What is the ratio of the Number of enrolments of both sexes of Andorra in 2004 to that in 2009?
Give a very brief answer. 0.83. What is the ratio of the Number of enrolments of both sexes of Montenegro in 2004 to that in 2009?
Keep it short and to the point. 1.01. What is the ratio of the Number of enrolments of both sexes in East Asia (developing only) in 2005 to that in 2006?
Your answer should be compact. 0.99. What is the ratio of the Number of enrolments of both sexes of Andorra in 2005 to that in 2006?
Offer a terse response. 0.97. What is the ratio of the Number of enrolments of both sexes in Montenegro in 2005 to that in 2006?
Ensure brevity in your answer.  1. What is the ratio of the Number of enrolments of both sexes of East Asia (developing only) in 2005 to that in 2007?
Offer a very short reply. 0.97. What is the ratio of the Number of enrolments of both sexes of North America in 2005 to that in 2007?
Your response must be concise. 0.99. What is the ratio of the Number of enrolments of both sexes of Andorra in 2005 to that in 2007?
Provide a short and direct response. 0.98. What is the ratio of the Number of enrolments of both sexes in Montenegro in 2005 to that in 2007?
Provide a short and direct response. 1.01. What is the ratio of the Number of enrolments of both sexes in East Asia (developing only) in 2005 to that in 2008?
Offer a terse response. 0.97. What is the ratio of the Number of enrolments of both sexes in Andorra in 2005 to that in 2008?
Your answer should be compact. 0.97. What is the ratio of the Number of enrolments of both sexes in Montenegro in 2005 to that in 2008?
Ensure brevity in your answer.  1.02. What is the ratio of the Number of enrolments of both sexes in East Asia (developing only) in 2005 to that in 2009?
Give a very brief answer. 0.97. What is the ratio of the Number of enrolments of both sexes in North America in 2005 to that in 2009?
Make the answer very short. 0.99. What is the ratio of the Number of enrolments of both sexes in Andorra in 2005 to that in 2009?
Give a very brief answer. 0.95. What is the ratio of the Number of enrolments of both sexes of Montenegro in 2005 to that in 2009?
Offer a very short reply. 1. What is the ratio of the Number of enrolments of both sexes in East Asia (developing only) in 2006 to that in 2007?
Provide a short and direct response. 0.98. What is the ratio of the Number of enrolments of both sexes in North America in 2006 to that in 2007?
Provide a short and direct response. 0.99. What is the ratio of the Number of enrolments of both sexes in Andorra in 2006 to that in 2007?
Provide a succinct answer. 1.01. What is the ratio of the Number of enrolments of both sexes of Montenegro in 2006 to that in 2007?
Provide a short and direct response. 1.01. What is the ratio of the Number of enrolments of both sexes of East Asia (developing only) in 2006 to that in 2008?
Make the answer very short. 0.98. What is the ratio of the Number of enrolments of both sexes in North America in 2006 to that in 2008?
Ensure brevity in your answer.  0.99. What is the ratio of the Number of enrolments of both sexes of Andorra in 2006 to that in 2008?
Your answer should be very brief. 1. What is the ratio of the Number of enrolments of both sexes in East Asia (developing only) in 2006 to that in 2009?
Your response must be concise. 0.98. What is the ratio of the Number of enrolments of both sexes of Andorra in 2006 to that in 2009?
Provide a succinct answer. 0.98. What is the ratio of the Number of enrolments of both sexes of East Asia (developing only) in 2007 to that in 2008?
Your answer should be compact. 1. What is the ratio of the Number of enrolments of both sexes of North America in 2007 to that in 2008?
Your answer should be very brief. 1. What is the ratio of the Number of enrolments of both sexes of Andorra in 2007 to that in 2008?
Ensure brevity in your answer.  0.99. What is the ratio of the Number of enrolments of both sexes of Montenegro in 2007 to that in 2008?
Provide a short and direct response. 1.01. What is the ratio of the Number of enrolments of both sexes in North America in 2007 to that in 2009?
Give a very brief answer. 1.01. What is the ratio of the Number of enrolments of both sexes of Andorra in 2007 to that in 2009?
Your response must be concise. 0.98. What is the ratio of the Number of enrolments of both sexes of East Asia (developing only) in 2008 to that in 2009?
Offer a very short reply. 1. What is the ratio of the Number of enrolments of both sexes in North America in 2008 to that in 2009?
Give a very brief answer. 1.01. What is the ratio of the Number of enrolments of both sexes in Andorra in 2008 to that in 2009?
Offer a terse response. 0.98. What is the ratio of the Number of enrolments of both sexes in Montenegro in 2008 to that in 2009?
Provide a short and direct response. 0.98. What is the difference between the highest and the second highest Number of enrolments of both sexes in East Asia (developing only)?
Provide a short and direct response. 3.27e+05. What is the difference between the highest and the second highest Number of enrolments of both sexes in North America?
Make the answer very short. 2.74e+04. What is the difference between the highest and the second highest Number of enrolments of both sexes of Montenegro?
Keep it short and to the point. 336. What is the difference between the highest and the lowest Number of enrolments of both sexes in East Asia (developing only)?
Provide a short and direct response. 6.07e+06. What is the difference between the highest and the lowest Number of enrolments of both sexes in North America?
Your response must be concise. 6.19e+05. What is the difference between the highest and the lowest Number of enrolments of both sexes in Andorra?
Offer a very short reply. 664. What is the difference between the highest and the lowest Number of enrolments of both sexes of Montenegro?
Make the answer very short. 1792. 